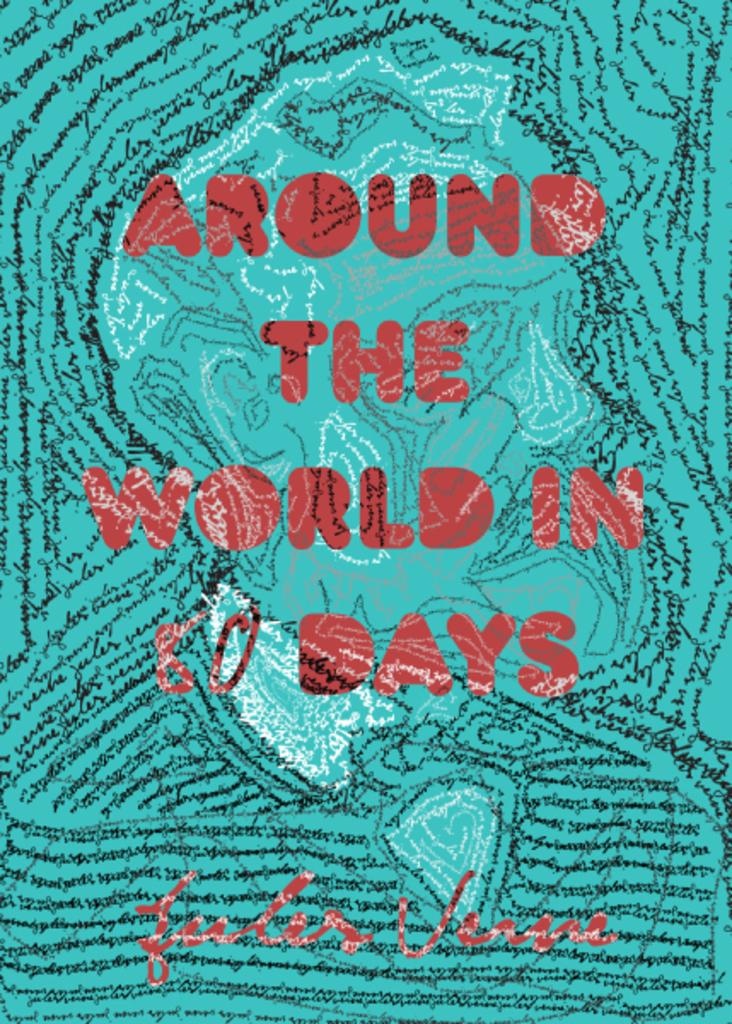<image>
Offer a succinct explanation of the picture presented. Turquoise book cover from a book called "Around The World in 80 Days". 